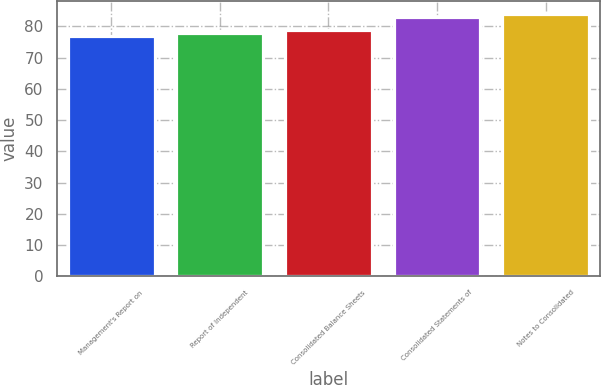Convert chart to OTSL. <chart><loc_0><loc_0><loc_500><loc_500><bar_chart><fcel>Management's Report on<fcel>Report of Independent<fcel>Consolidated Balance Sheets<fcel>Consolidated Statements of<fcel>Notes to Consolidated<nl><fcel>77<fcel>78<fcel>79<fcel>83<fcel>84<nl></chart> 